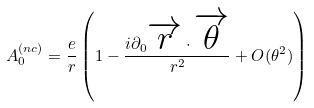Convert formula to latex. <formula><loc_0><loc_0><loc_500><loc_500>A _ { 0 } ^ { ( n c ) } = \frac { e } { r } \left ( 1 - \frac { i \partial _ { 0 } \overrightarrow { r } \cdot \overrightarrow { \theta } } { r ^ { 2 } } + O ( \theta ^ { 2 } ) \right )</formula> 